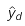Convert formula to latex. <formula><loc_0><loc_0><loc_500><loc_500>\hat { y } _ { d }</formula> 